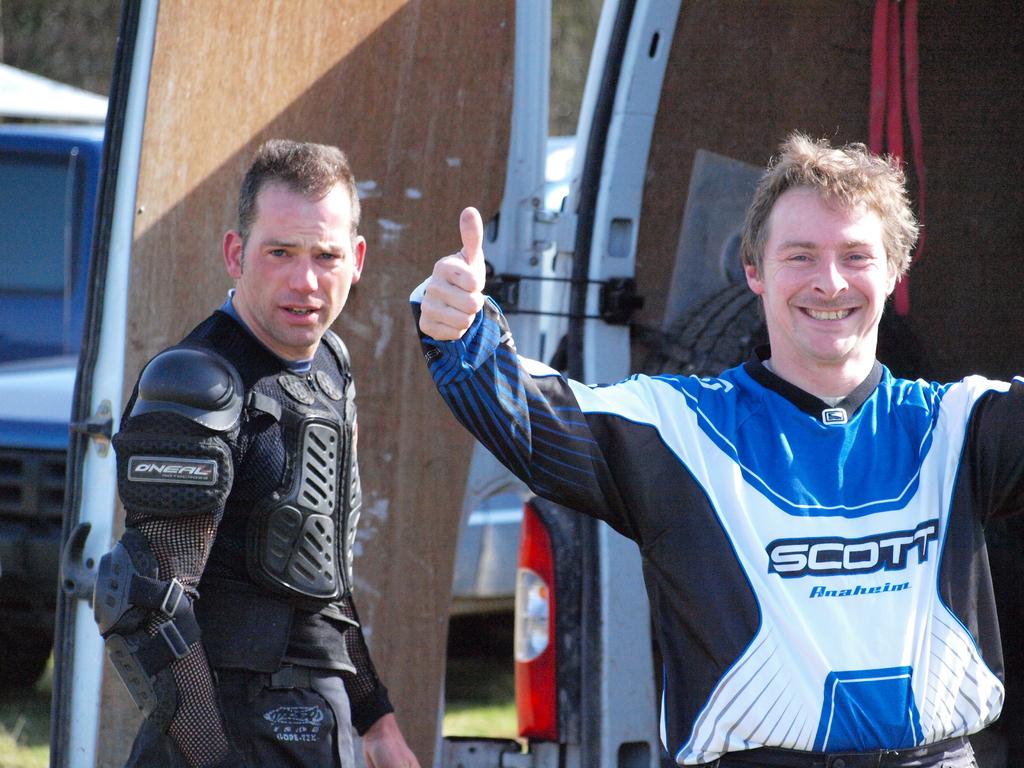What is the jersey sponsor?
Provide a succinct answer. Scott. 